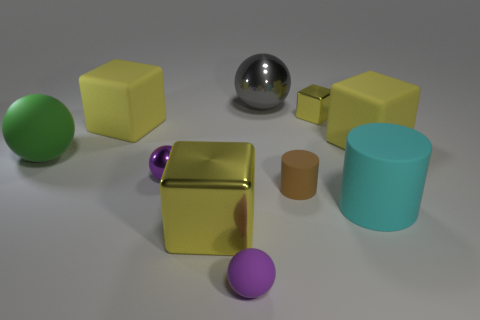What is the material of the other tiny sphere that is the same color as the small metal sphere?
Offer a terse response. Rubber. There is a big yellow object in front of the large rubber block to the right of the cyan object; what number of large yellow matte cubes are to the left of it?
Make the answer very short. 1. There is a gray thing that is the same shape as the small purple metal object; what size is it?
Provide a short and direct response. Large. Do the big sphere behind the small yellow thing and the small yellow cube have the same material?
Keep it short and to the point. Yes. What color is the small object that is the same shape as the large yellow shiny object?
Your answer should be very brief. Yellow. How many other things are there of the same color as the tiny block?
Your answer should be very brief. 3. There is a large matte thing that is in front of the purple metal sphere; is its shape the same as the small rubber object that is to the right of the small purple rubber object?
Your response must be concise. Yes. What number of cylinders are either large blue rubber things or metallic objects?
Make the answer very short. 0. Are there fewer small rubber spheres that are in front of the small rubber cylinder than tiny brown metal spheres?
Keep it short and to the point. No. How many other objects are the same material as the large cyan cylinder?
Provide a succinct answer. 5. 